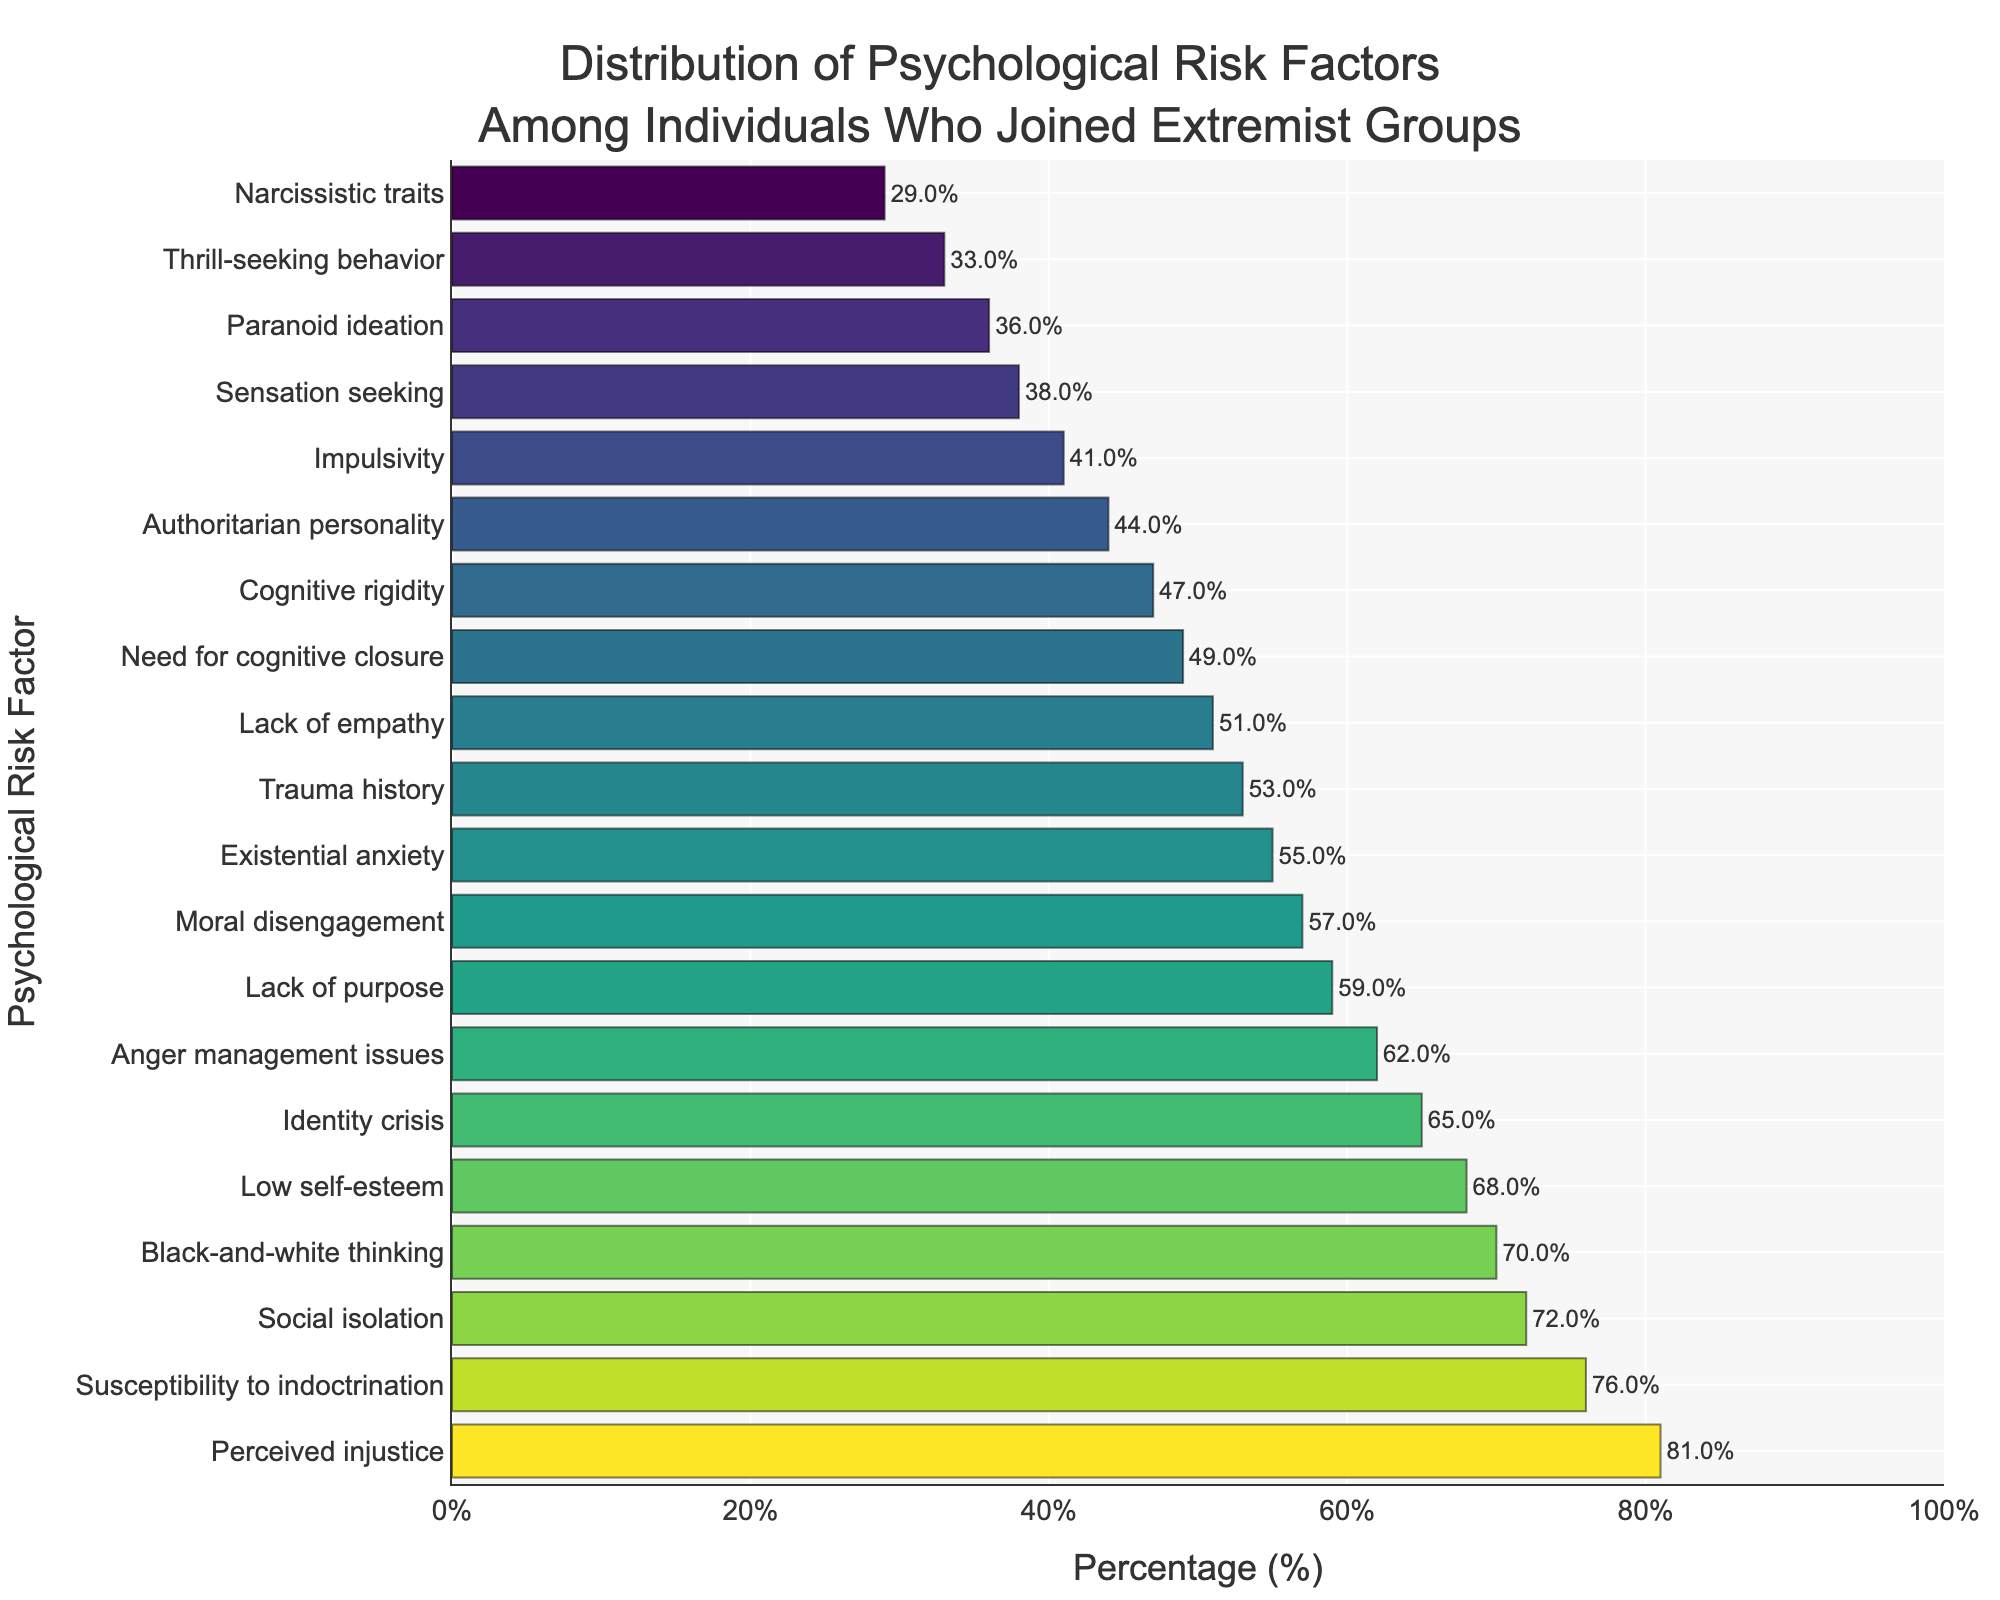Which psychological risk factor has the highest percentage among individuals who joined extremist groups? The bar chart shows the percentage values for various psychological risk factors. The highest bar corresponds to "Perceived injustice" with a percentage of 81%.
Answer: Perceived injustice What is the difference in percentage between "Social isolation" and "Low self-esteem"? The chart shows "Social isolation" at 72% and "Low self-esteem" at 68%. The difference is calculated as 72% - 68% = 4%.
Answer: 4% How many psychological risk factors have a percentage higher than 60%? We need to count the bars with percentages greater than 60%. They are "Social isolation" (72%), "Perceived injustice" (81%), "Black-and-white thinking" (70%), "Low self-esteem" (68%), and "Anger management issues" (62%). So, there are 5 factors.
Answer: 5 Which psychological risk factor has a percentage closest to 50%? The closest percentage to 50% on the chart is "Need for cognitive closure" with a percentage of 49%.
Answer: Need for cognitive closure What is the combined percentage of "Trauma history" and "Lack of empathy"? "Trauma history" has a percentage of 53% and "Lack of empathy" has a percentage of 51%. The combined percentage is 53% + 51% = 104%.
Answer: 104% Which risk factor has a lower percentage, "Narcissistic traits" or "Paranoid ideation"? The chart shows "Narcissistic traits" at 29% and "Paranoid ideation" at 36%. Since 29% is less than 36%, "Narcissistic traits" has a lower percentage.
Answer: Narcissistic traits How does the percentage of "Impulsivity" compare to that of "Cognitive rigidity"? The chart shows "Impulsivity" at 41% and "Cognitive rigidity" at 47%. Since 41% is less than 47%, "Impulsivity" has a lower percentage.
Answer: Less than What is the visual color pattern for psychological risk factors with percentages above 70%? The bars corresponding to percentages above 70% are "Social isolation" (72%), "Black-and-white thinking" (70%), and "Susceptibility to indoctrination" (76%). These bars are in shades of the same colorscheme, with higher intensity correlating with higher percentages.
Answer: Shades of similar color with higher intensity What is the average percentage for "Existential anxiety", "Lack of purpose", and "Moral disengagement"? "Existential anxiety" has 55%, "Lack of purpose" has 59%, and "Moral disengagement" has 57%. The average is (55 + 59 + 57) / 3 = 171 / 3 = 57%.
Answer: 57% Which psychological risk factor has the highest percentage among the ones starting with the letter 'N'? The factors starting with 'N' are "Narcissistic traits" (29%) and "Need for cognitive closure" (49%). Since 49% is greater than 29%, "Need for cognitive closure" has the highest percentage.
Answer: Need for cognitive closure 